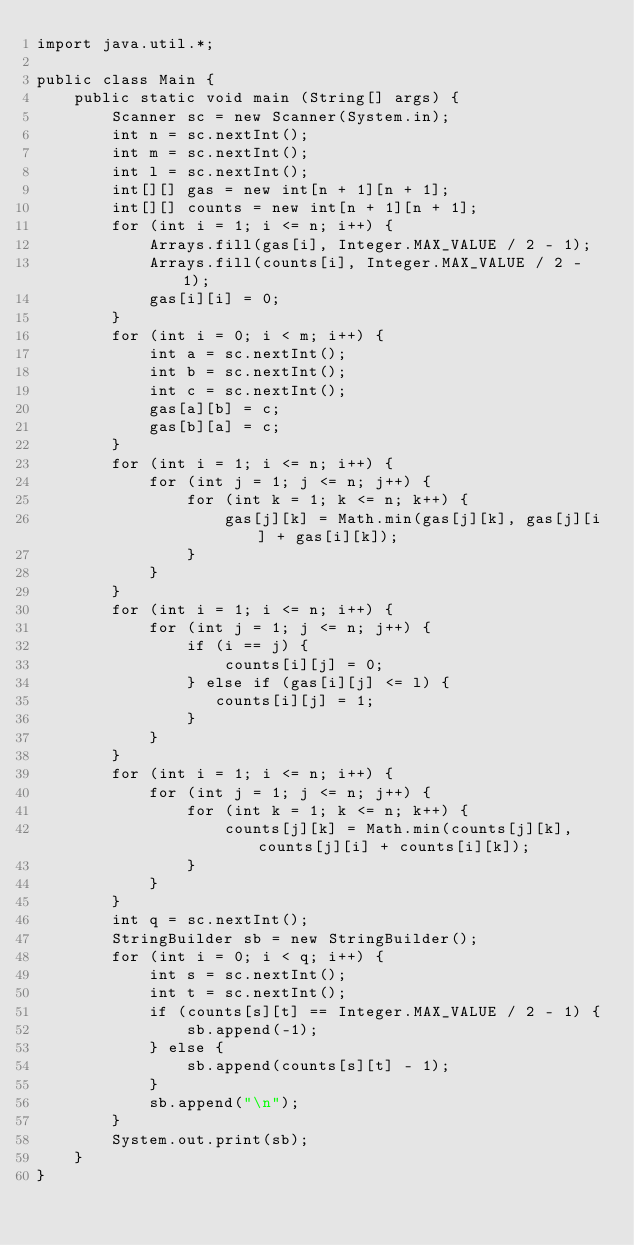<code> <loc_0><loc_0><loc_500><loc_500><_Java_>import java.util.*;

public class Main {
	public static void main (String[] args) {
		Scanner sc = new Scanner(System.in);
		int n = sc.nextInt();
		int m = sc.nextInt();
		int l = sc.nextInt();
		int[][] gas = new int[n + 1][n + 1];
		int[][] counts = new int[n + 1][n + 1];
		for (int i = 1; i <= n; i++) {
		    Arrays.fill(gas[i], Integer.MAX_VALUE / 2 - 1);
		    Arrays.fill(counts[i], Integer.MAX_VALUE / 2 - 1);
		    gas[i][i] = 0;
		}
		for (int i = 0; i < m; i++) {
		    int a = sc.nextInt();
		    int b = sc.nextInt();
		    int c = sc.nextInt();
		    gas[a][b] = c;
		    gas[b][a] = c;
		}
		for (int i = 1; i <= n; i++) {
		    for (int j = 1; j <= n; j++) {
		        for (int k = 1; k <= n; k++) {
		            gas[j][k] = Math.min(gas[j][k], gas[j][i] + gas[i][k]);
		        }
		    }
		}
		for (int i = 1; i <= n; i++) {
		    for (int j = 1; j <= n; j++) {
		        if (i == j) {
		            counts[i][j] = 0;
		        } else if (gas[i][j] <= l) {
		           counts[i][j] = 1;
		        }
		    }
		}
		for (int i = 1; i <= n; i++) {
		    for (int j = 1; j <= n; j++) {
		        for (int k = 1; k <= n; k++) {
		            counts[j][k] = Math.min(counts[j][k], counts[j][i] + counts[i][k]);
		        }
		    }
		}
		int q = sc.nextInt();
		StringBuilder sb = new StringBuilder();
		for (int i = 0; i < q; i++) {
		    int s = sc.nextInt();
		    int t = sc.nextInt();
		    if (counts[s][t] == Integer.MAX_VALUE / 2 - 1) {
		        sb.append(-1);
		    } else {
		        sb.append(counts[s][t] - 1);
		    }
		    sb.append("\n");
		}
		System.out.print(sb);
	}
}
</code> 